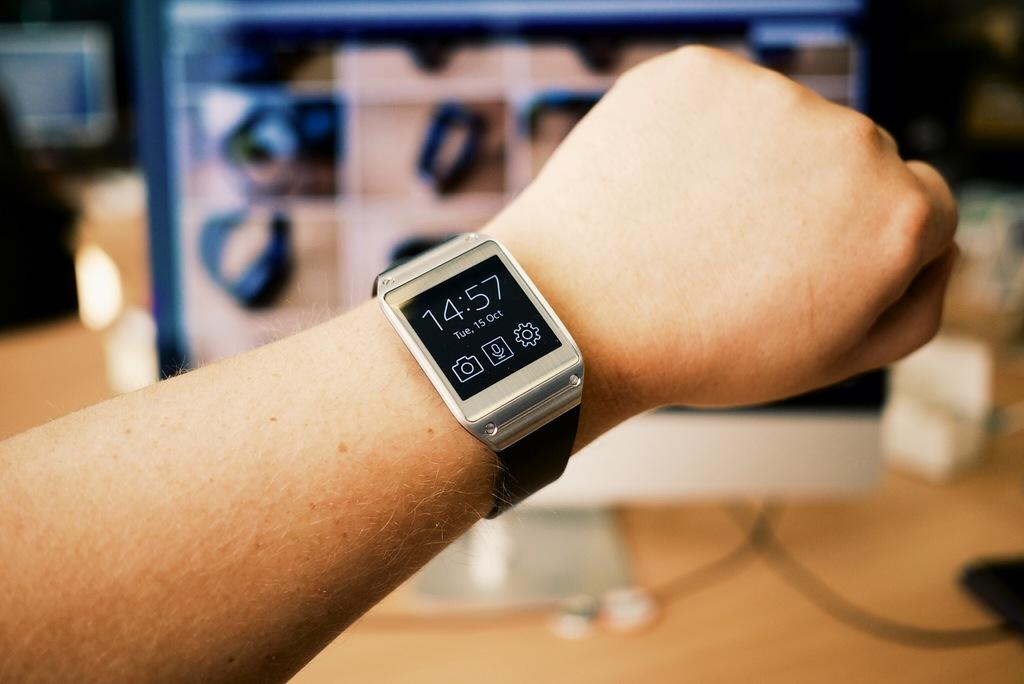<image>
Relay a brief, clear account of the picture shown. A watch shown on a person's wrist showing the time 14:57 and the date Tue, 15 Oct. 